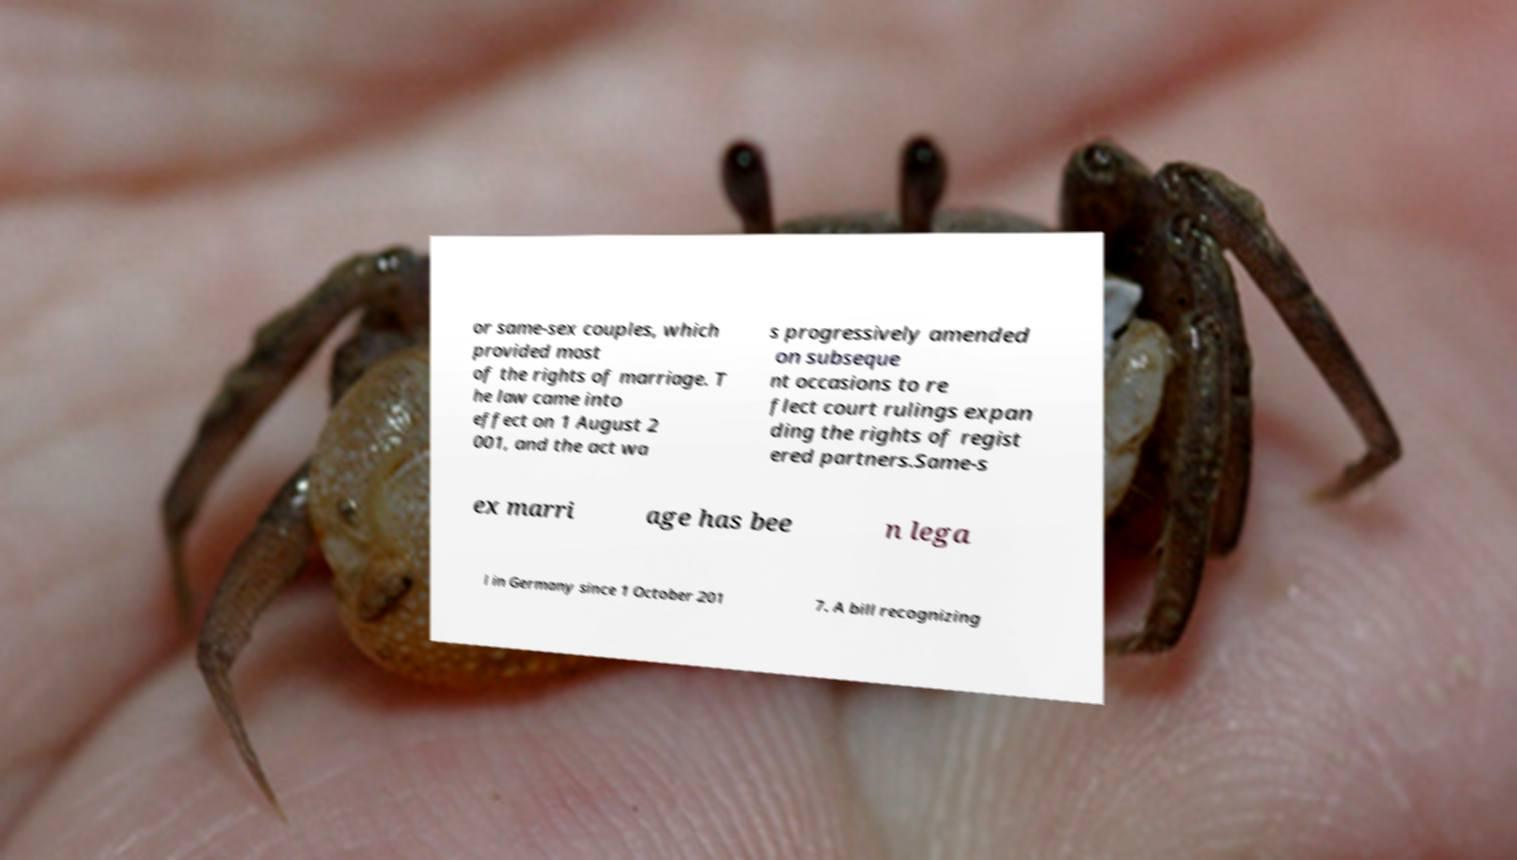I need the written content from this picture converted into text. Can you do that? or same-sex couples, which provided most of the rights of marriage. T he law came into effect on 1 August 2 001, and the act wa s progressively amended on subseque nt occasions to re flect court rulings expan ding the rights of regist ered partners.Same-s ex marri age has bee n lega l in Germany since 1 October 201 7. A bill recognizing 